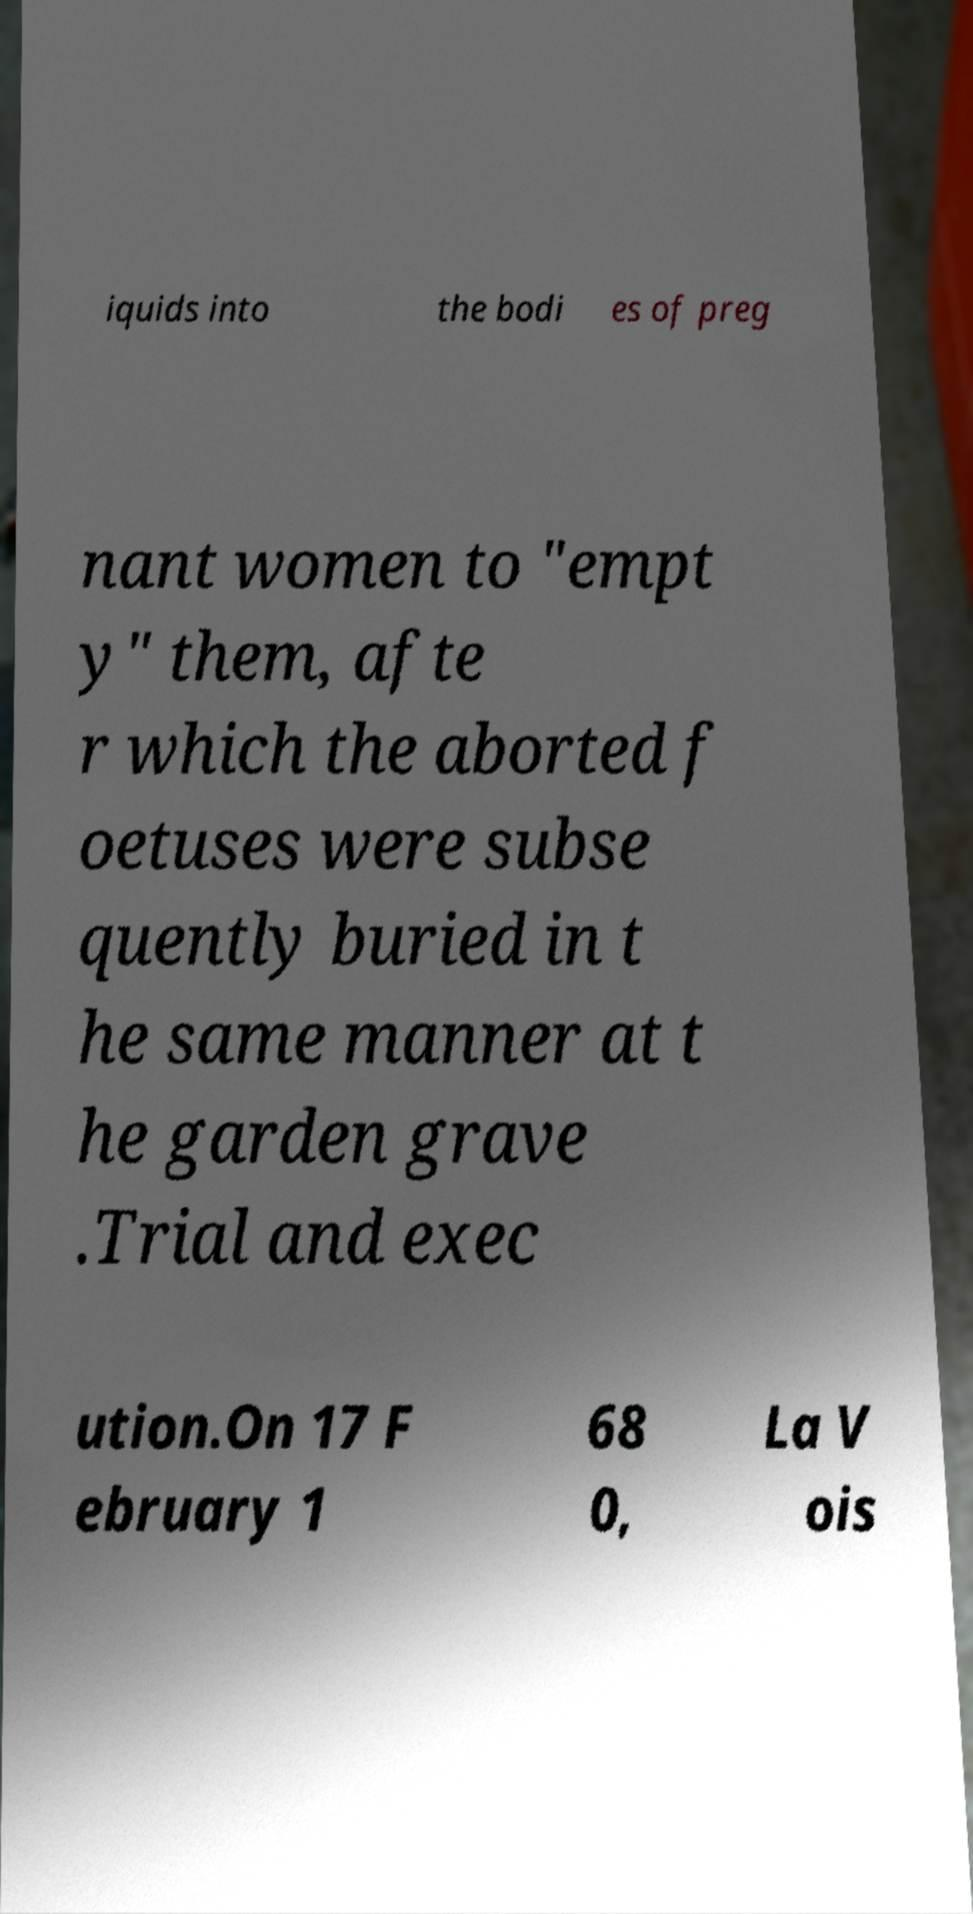Could you assist in decoding the text presented in this image and type it out clearly? iquids into the bodi es of preg nant women to "empt y" them, afte r which the aborted f oetuses were subse quently buried in t he same manner at t he garden grave .Trial and exec ution.On 17 F ebruary 1 68 0, La V ois 